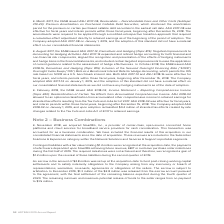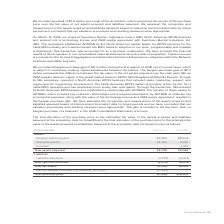According to Adtran's financial document, What kind of service did SmartRG, Inc. provide? carrier-class, open-source connected home platforms and cloud services for broadband service providers for cash consideration.. The document states: "ber 2018, we acquired SmartRG, Inc., a provider of carrier-class, open-source connected home platforms and cloud services for broadband service provid..." Also, What was the tangible assets aquired from Sumitomo? According to the financial document, 1,006 (in thousands). The relevant text states: "Tangible assets aquired $1,006 $8,594..." Also, How much were the intangible assets from SmartRG? According to the financial document, 9,960 (in thousands). The relevant text states: "Intangible assets 22,100 9,960..." Also, can you calculate: What was the difference in tangible assets acquired between Sumitomo and SmartRG? Based on the calculation: $8,594-$1,006, the result is 7588 (in thousands). This is based on the information: "Tangible assets aquired $1,006 $8,594 Tangible assets aquired $1,006 $8,594..." The key data points involved are: 1,006, 8,594. Also, can you calculate: What was the difference in total purchase price between Sumitomo and SmartRG? Based on the calculation: $16,029-$7,806, the result is 8223 (in thousands). This is based on the information: "Total purchase price $7,806 $16,029 Total purchase price $7,806 $16,029..." The key data points involved are: 16,029, 7,806. Also, can you calculate: What is the total net assets of SmartRG as a ratio of the total net assets of Sumitomo? Based on the calculation: 16,029/19,128, the result is 0.84. This is based on the information: "Total net assets 19,128 16,029 Total net assets 19,128 16,029..." The key data points involved are: 16,029, 19,128. 